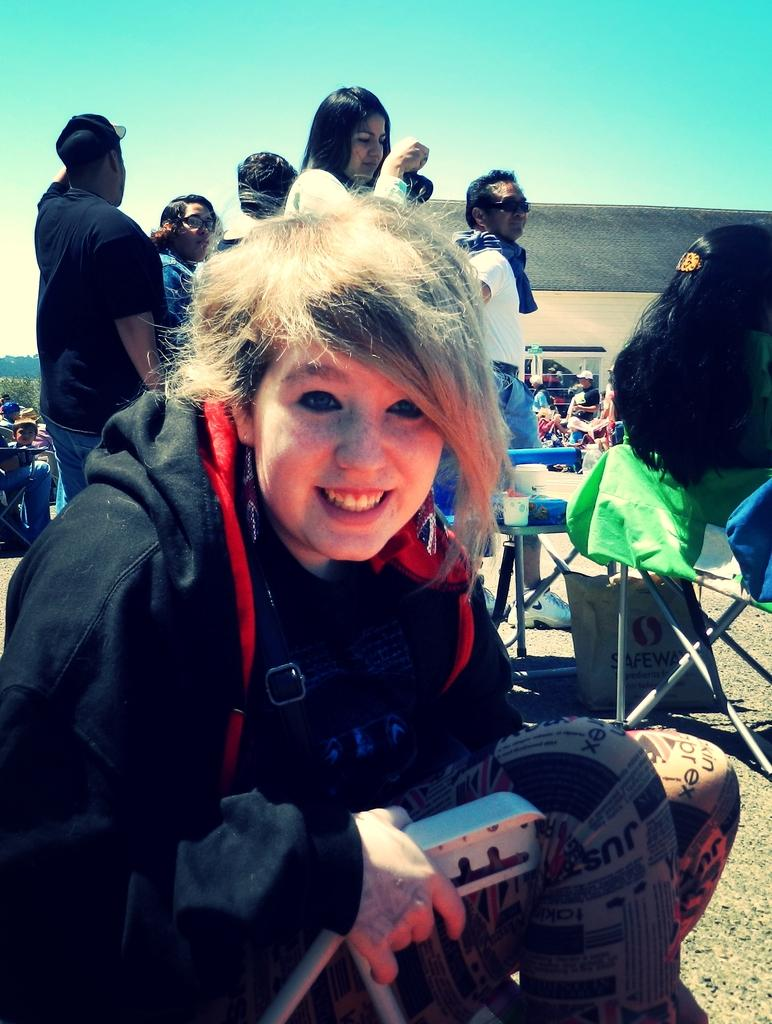How many people are in the image? There are people in the image, but the exact number is not specified. What are some of the people doing in the image? Some people are sitting on chairs, while others are standing. Can you describe the facial expression of one of the people? There is a smile on someone's face. What can be seen in the background of the image? There is a carry bag in the background, and the sky is visible. Where is the shelf located in the image? There is no shelf present in the image. Can you describe the stretch of the kitten in the image? There is no kitten present in the image. 